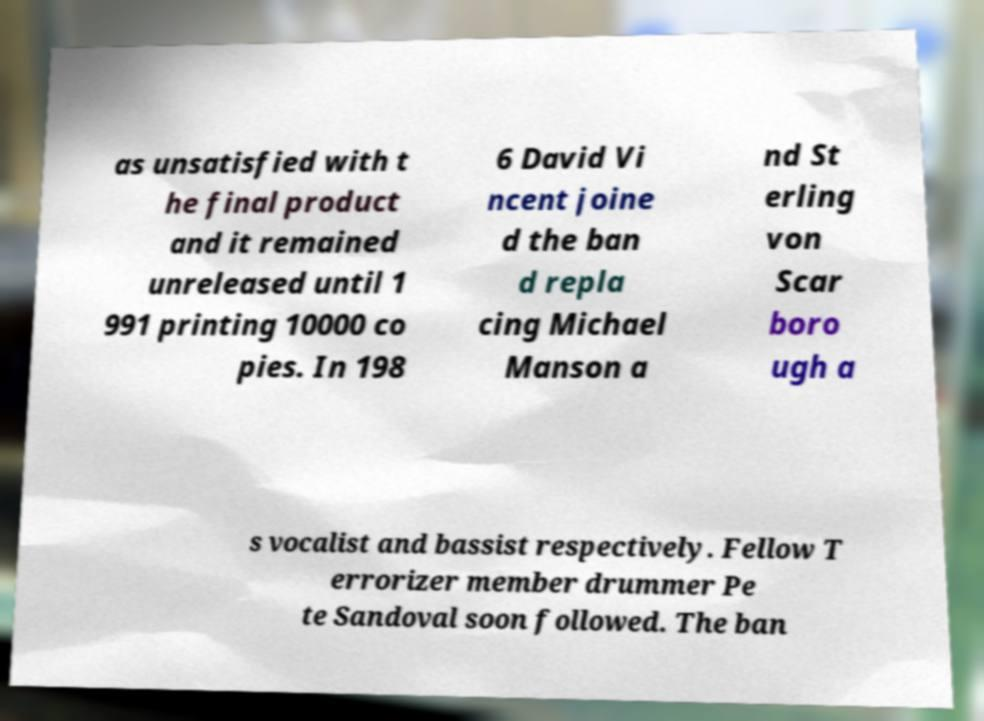Can you accurately transcribe the text from the provided image for me? as unsatisfied with t he final product and it remained unreleased until 1 991 printing 10000 co pies. In 198 6 David Vi ncent joine d the ban d repla cing Michael Manson a nd St erling von Scar boro ugh a s vocalist and bassist respectively. Fellow T errorizer member drummer Pe te Sandoval soon followed. The ban 